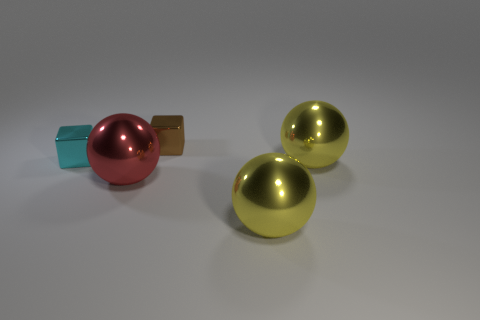Add 2 large yellow objects. How many objects exist? 7 Subtract all cubes. How many objects are left? 3 Add 4 yellow metallic balls. How many yellow metallic balls exist? 6 Subtract 0 blue spheres. How many objects are left? 5 Subtract all small yellow metal cylinders. Subtract all metallic cubes. How many objects are left? 3 Add 3 big shiny balls. How many big shiny balls are left? 6 